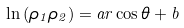Convert formula to latex. <formula><loc_0><loc_0><loc_500><loc_500>\ln \left ( \rho _ { 1 } \rho _ { 2 } \right ) = a r \cos \theta + b</formula> 